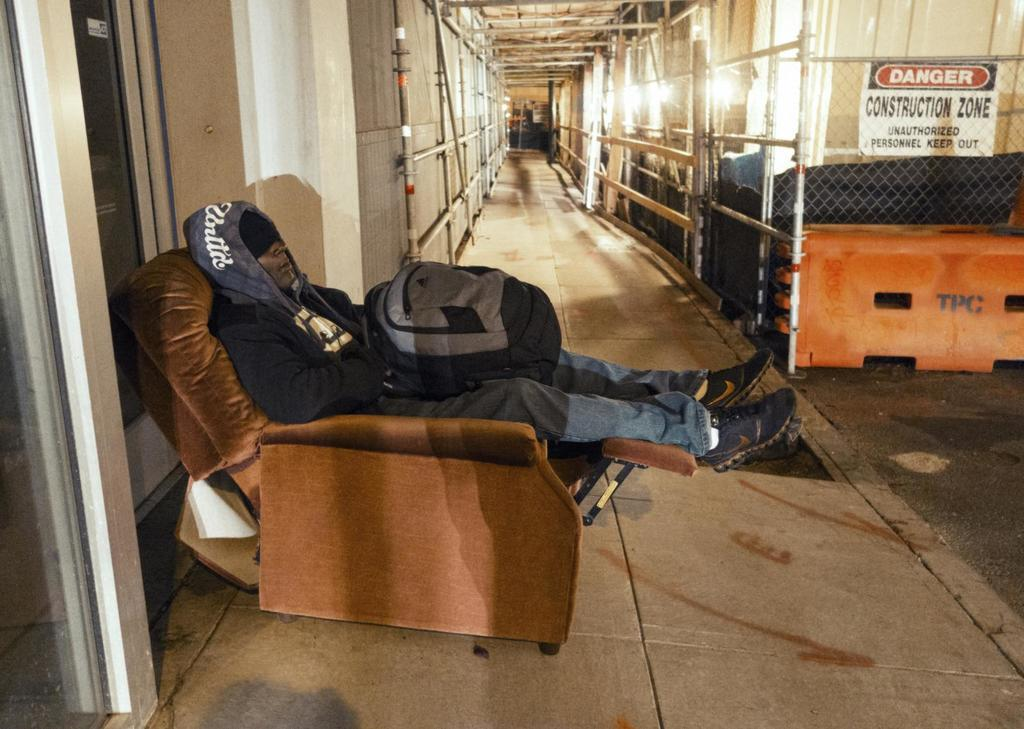What is the person in the image doing? The person is laying on a chair in the image. What is the person carrying or wearing on their back? The person has a backpack on them. What is in front of the person? There is a fencing in front of the person. What warning or caution is indicated in the image? There is a danger board in the image. How does the person in the image connect with the pan? There is no pan present in the image, so the person cannot connect with it. 